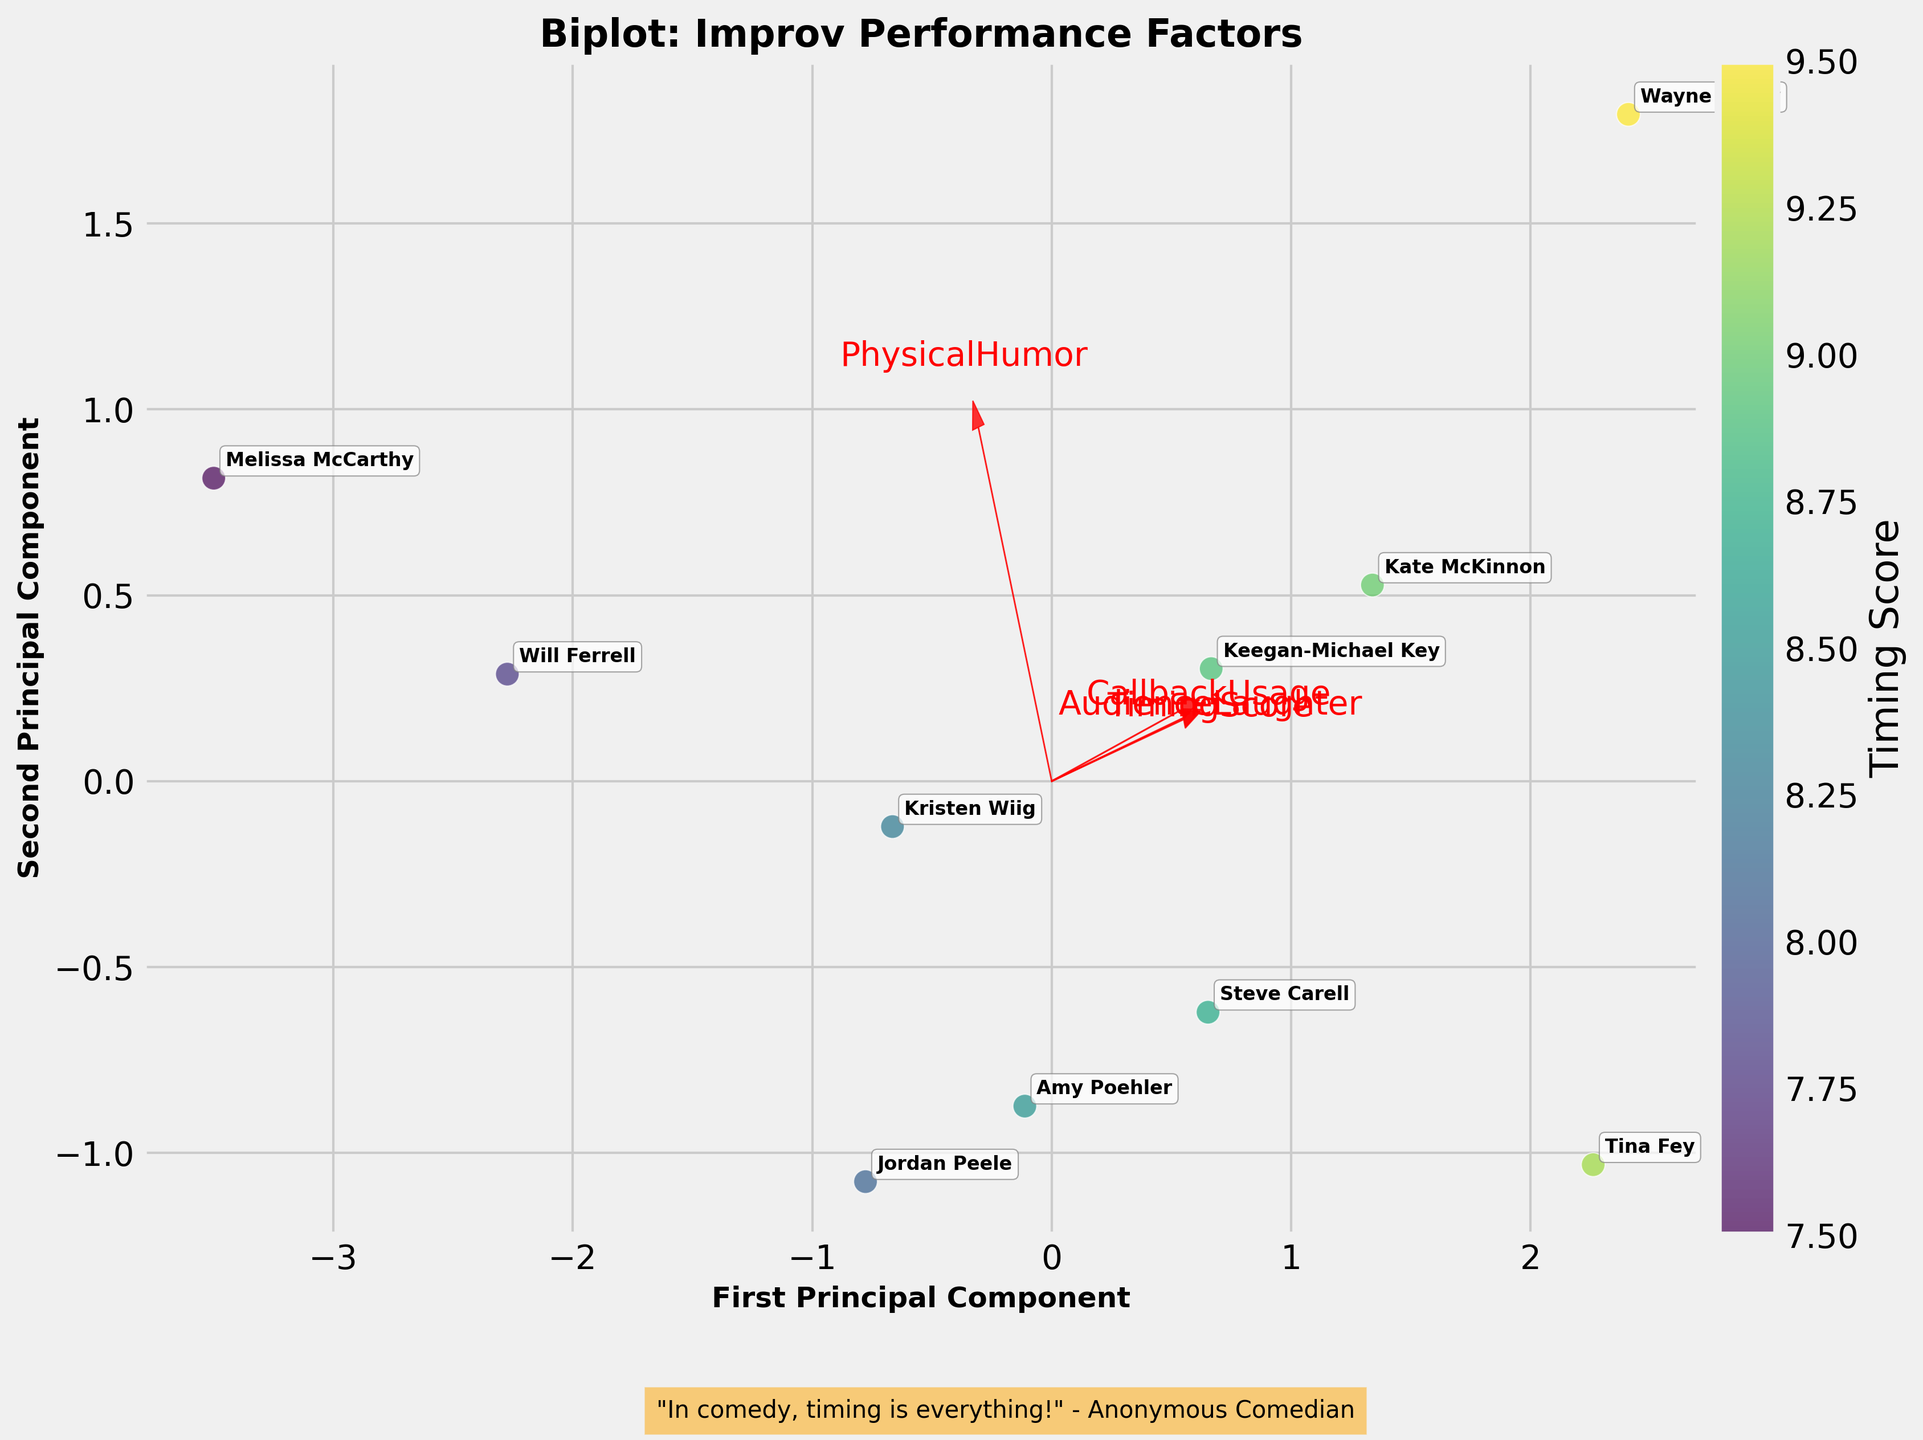What's the title of the plot? The title of the plot is usually located at the top center of the figure and provides a concise description of the content. In this figure, the title is "Biplot: Improv Performance Factors".
Answer: Biplot: Improv Performance Factors How is comedic timing represented on the biplot? The TimingScore is one of the variables included in the PCA biplot analysis, and it is represented by the color gradient of the data points, with different shades indicating different values.
Answer: By the color gradient of the data points How many comedians are shown in the biplot? Each data point represents a different comedian, and their names are labeled on the plot. By counting the labels, you can determine the number of comedians.
Answer: 10 How are the vectors for performance factors depicted? The vectors for performance factors like CallbackUsage, PhysicalHumor, AudienceLaughter, and TimingScore are shown as red arrows originating from the center and pointing in the direction of increasing values for each factor.
Answer: Red arrows Which comedian has the highest TimingScore, and how can you tell? The TimingScore is represented by the color gradient of the data points. The comedian Wayne Brady has the highest TimingScore because his point is in the darkest shade of the gradient, indicating the highest score.
Answer: Wayne Brady Do any comedians have similar PCA scores? You can identify comedians with similar PCA scores by looking for data points that are close to each other on the plot. For example, Tina Fey and Kate McKinnon are located near each other, suggesting similar PCA scores.
Answer: Tina Fey and Kate McKinnon Which performance factor seems to influence the first principal component the most? The influence of each performance factor on the principal components can be inferred from the lengths and direction of the arrows. The factor with the longest arrow along the first principal component axis (x-axis) likely has the most significant influence. In this case, it appears that AudienceLaughter has the strongest influence.
Answer: AudienceLaughter Are there any performance factors that appear to be positively correlated? Positive correlation between performance factors is indicated by arrows pointing in the same or similar directions. In this plot, AudienceLaughter and CallbackUsage appear to be positively correlated as their arrows point in similar directions.
Answer: AudienceLaughter and CallbackUsage Which comedian appears to use PhysicalHumor the most, and how do you know? The use of PhysicalHumor by a comedian can be inferred by observing their position in relation to the PhysicalHumor arrow. Melissa McCarthy is closest to the PhysicalHumor arrow's direction, suggesting she uses it the most.
Answer: Melissa McCarthy 